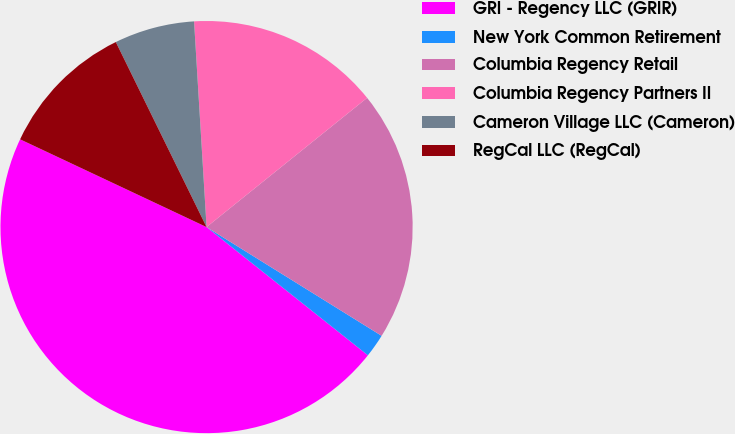<chart> <loc_0><loc_0><loc_500><loc_500><pie_chart><fcel>GRI - Regency LLC (GRIR)<fcel>New York Common Retirement<fcel>Columbia Regency Retail<fcel>Columbia Regency Partners II<fcel>Cameron Village LLC (Cameron)<fcel>RegCal LLC (RegCal)<nl><fcel>46.31%<fcel>1.84%<fcel>19.63%<fcel>15.18%<fcel>6.29%<fcel>10.74%<nl></chart> 